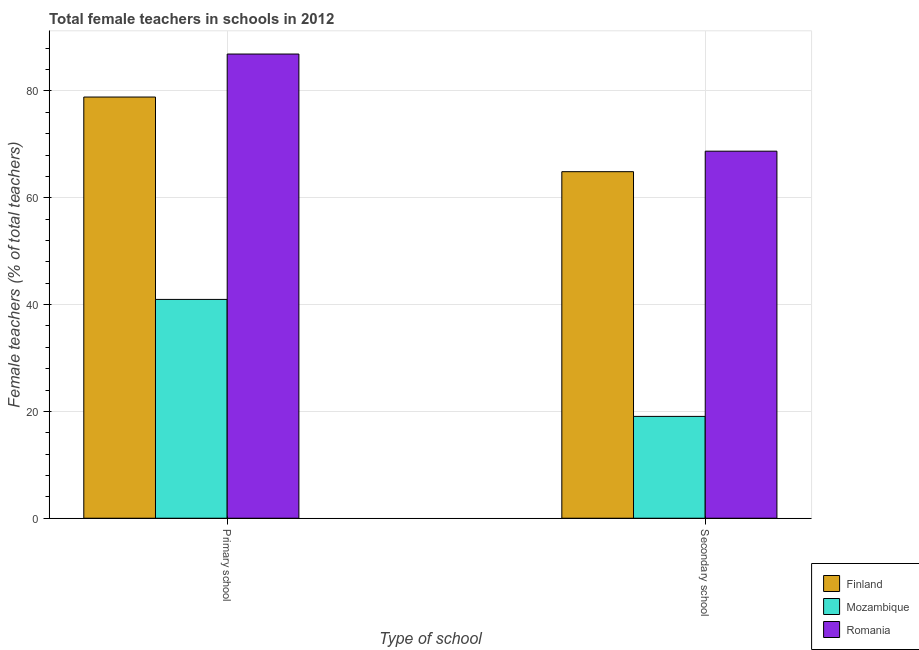How many groups of bars are there?
Your answer should be very brief. 2. How many bars are there on the 1st tick from the left?
Offer a very short reply. 3. What is the label of the 2nd group of bars from the left?
Ensure brevity in your answer.  Secondary school. What is the percentage of female teachers in primary schools in Finland?
Your answer should be very brief. 78.86. Across all countries, what is the maximum percentage of female teachers in primary schools?
Keep it short and to the point. 86.91. Across all countries, what is the minimum percentage of female teachers in primary schools?
Your answer should be very brief. 40.97. In which country was the percentage of female teachers in secondary schools maximum?
Provide a short and direct response. Romania. In which country was the percentage of female teachers in primary schools minimum?
Your answer should be compact. Mozambique. What is the total percentage of female teachers in secondary schools in the graph?
Ensure brevity in your answer.  152.67. What is the difference between the percentage of female teachers in secondary schools in Mozambique and that in Romania?
Provide a short and direct response. -49.66. What is the difference between the percentage of female teachers in secondary schools in Mozambique and the percentage of female teachers in primary schools in Finland?
Your response must be concise. -59.79. What is the average percentage of female teachers in primary schools per country?
Offer a terse response. 68.91. What is the difference between the percentage of female teachers in primary schools and percentage of female teachers in secondary schools in Finland?
Ensure brevity in your answer.  13.97. What is the ratio of the percentage of female teachers in primary schools in Romania to that in Mozambique?
Give a very brief answer. 2.12. In how many countries, is the percentage of female teachers in secondary schools greater than the average percentage of female teachers in secondary schools taken over all countries?
Your answer should be very brief. 2. What does the 2nd bar from the left in Secondary school represents?
Keep it short and to the point. Mozambique. How many countries are there in the graph?
Your response must be concise. 3. Does the graph contain any zero values?
Provide a succinct answer. No. What is the title of the graph?
Offer a very short reply. Total female teachers in schools in 2012. What is the label or title of the X-axis?
Provide a succinct answer. Type of school. What is the label or title of the Y-axis?
Your answer should be compact. Female teachers (% of total teachers). What is the Female teachers (% of total teachers) of Finland in Primary school?
Offer a very short reply. 78.86. What is the Female teachers (% of total teachers) of Mozambique in Primary school?
Make the answer very short. 40.97. What is the Female teachers (% of total teachers) of Romania in Primary school?
Provide a short and direct response. 86.91. What is the Female teachers (% of total teachers) of Finland in Secondary school?
Your response must be concise. 64.88. What is the Female teachers (% of total teachers) of Mozambique in Secondary school?
Your response must be concise. 19.07. What is the Female teachers (% of total teachers) of Romania in Secondary school?
Give a very brief answer. 68.72. Across all Type of school, what is the maximum Female teachers (% of total teachers) in Finland?
Offer a very short reply. 78.86. Across all Type of school, what is the maximum Female teachers (% of total teachers) in Mozambique?
Offer a very short reply. 40.97. Across all Type of school, what is the maximum Female teachers (% of total teachers) of Romania?
Ensure brevity in your answer.  86.91. Across all Type of school, what is the minimum Female teachers (% of total teachers) of Finland?
Your answer should be very brief. 64.88. Across all Type of school, what is the minimum Female teachers (% of total teachers) of Mozambique?
Your answer should be very brief. 19.07. Across all Type of school, what is the minimum Female teachers (% of total teachers) of Romania?
Provide a succinct answer. 68.72. What is the total Female teachers (% of total teachers) in Finland in the graph?
Offer a terse response. 143.74. What is the total Female teachers (% of total teachers) in Mozambique in the graph?
Offer a very short reply. 60.03. What is the total Female teachers (% of total teachers) in Romania in the graph?
Provide a succinct answer. 155.63. What is the difference between the Female teachers (% of total teachers) of Finland in Primary school and that in Secondary school?
Offer a very short reply. 13.97. What is the difference between the Female teachers (% of total teachers) of Mozambique in Primary school and that in Secondary school?
Keep it short and to the point. 21.9. What is the difference between the Female teachers (% of total teachers) of Romania in Primary school and that in Secondary school?
Your answer should be compact. 18.19. What is the difference between the Female teachers (% of total teachers) of Finland in Primary school and the Female teachers (% of total teachers) of Mozambique in Secondary school?
Offer a terse response. 59.79. What is the difference between the Female teachers (% of total teachers) of Finland in Primary school and the Female teachers (% of total teachers) of Romania in Secondary school?
Provide a short and direct response. 10.14. What is the difference between the Female teachers (% of total teachers) in Mozambique in Primary school and the Female teachers (% of total teachers) in Romania in Secondary school?
Provide a short and direct response. -27.75. What is the average Female teachers (% of total teachers) of Finland per Type of school?
Your response must be concise. 71.87. What is the average Female teachers (% of total teachers) in Mozambique per Type of school?
Offer a very short reply. 30.02. What is the average Female teachers (% of total teachers) in Romania per Type of school?
Your answer should be very brief. 77.82. What is the difference between the Female teachers (% of total teachers) of Finland and Female teachers (% of total teachers) of Mozambique in Primary school?
Offer a very short reply. 37.89. What is the difference between the Female teachers (% of total teachers) in Finland and Female teachers (% of total teachers) in Romania in Primary school?
Ensure brevity in your answer.  -8.05. What is the difference between the Female teachers (% of total teachers) in Mozambique and Female teachers (% of total teachers) in Romania in Primary school?
Make the answer very short. -45.94. What is the difference between the Female teachers (% of total teachers) of Finland and Female teachers (% of total teachers) of Mozambique in Secondary school?
Offer a very short reply. 45.82. What is the difference between the Female teachers (% of total teachers) of Finland and Female teachers (% of total teachers) of Romania in Secondary school?
Provide a short and direct response. -3.84. What is the difference between the Female teachers (% of total teachers) of Mozambique and Female teachers (% of total teachers) of Romania in Secondary school?
Give a very brief answer. -49.66. What is the ratio of the Female teachers (% of total teachers) in Finland in Primary school to that in Secondary school?
Your response must be concise. 1.22. What is the ratio of the Female teachers (% of total teachers) in Mozambique in Primary school to that in Secondary school?
Provide a short and direct response. 2.15. What is the ratio of the Female teachers (% of total teachers) in Romania in Primary school to that in Secondary school?
Your response must be concise. 1.26. What is the difference between the highest and the second highest Female teachers (% of total teachers) of Finland?
Provide a succinct answer. 13.97. What is the difference between the highest and the second highest Female teachers (% of total teachers) in Mozambique?
Your answer should be very brief. 21.9. What is the difference between the highest and the second highest Female teachers (% of total teachers) of Romania?
Provide a succinct answer. 18.19. What is the difference between the highest and the lowest Female teachers (% of total teachers) of Finland?
Offer a terse response. 13.97. What is the difference between the highest and the lowest Female teachers (% of total teachers) of Mozambique?
Provide a short and direct response. 21.9. What is the difference between the highest and the lowest Female teachers (% of total teachers) of Romania?
Ensure brevity in your answer.  18.19. 